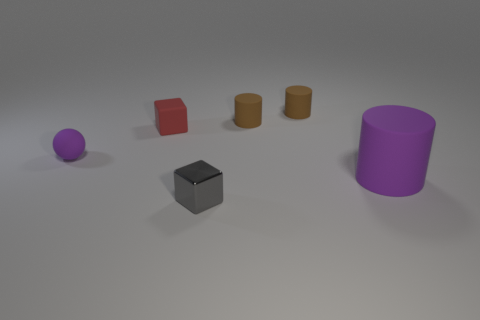Add 3 gray metallic things. How many objects exist? 9 Subtract all blocks. How many objects are left? 4 Add 6 big purple rubber things. How many big purple rubber things are left? 7 Add 1 small metal cubes. How many small metal cubes exist? 2 Subtract 0 red balls. How many objects are left? 6 Subtract all tiny red things. Subtract all large purple rubber cylinders. How many objects are left? 4 